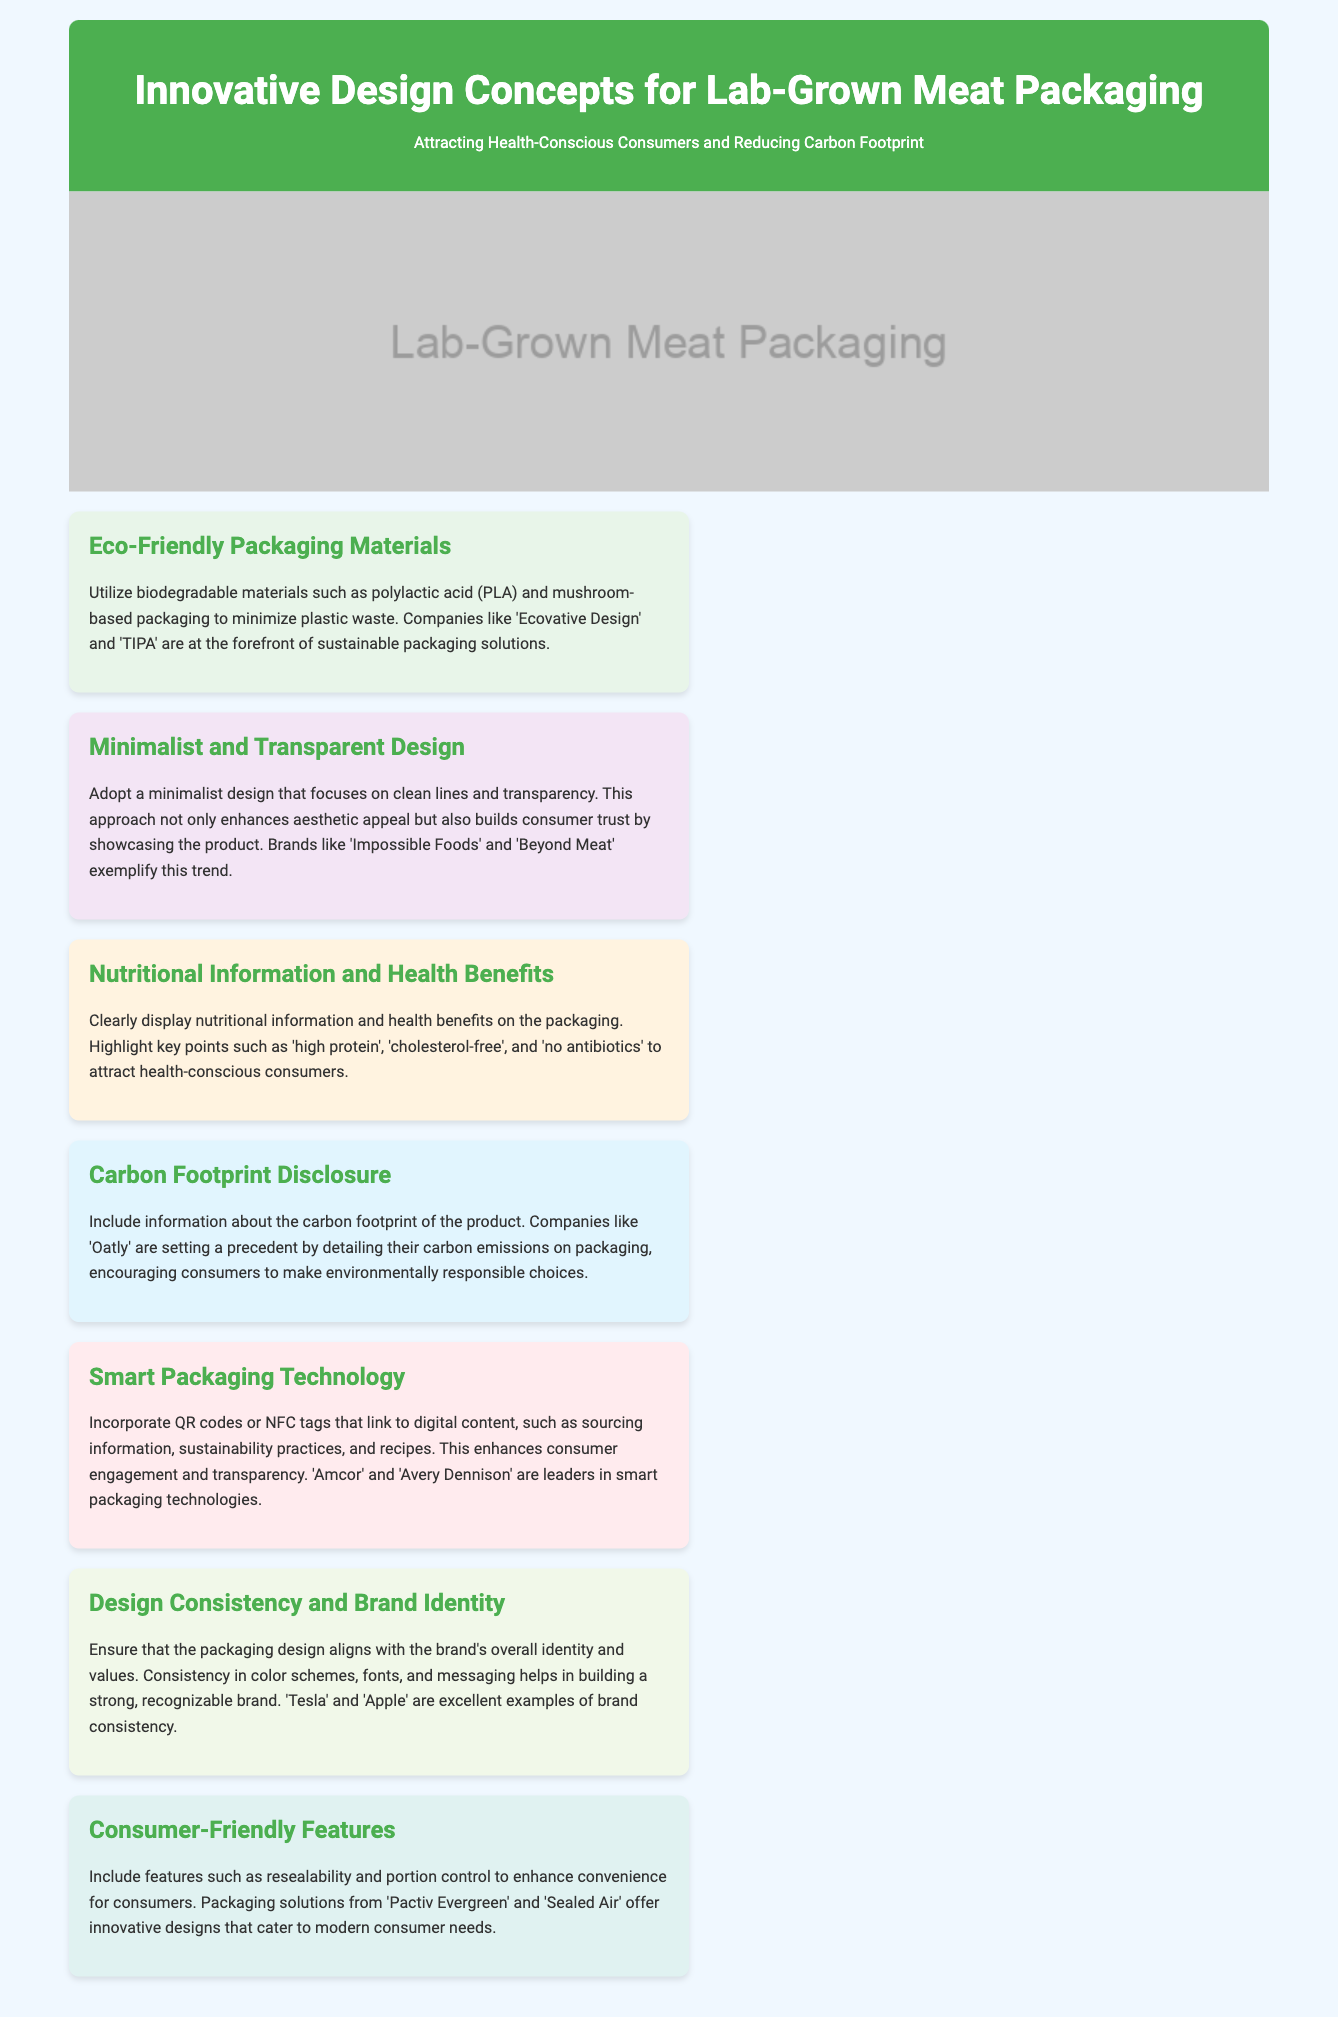What are the eco-friendly packaging materials mentioned? The document mentions biodegradable materials such as polylactic acid (PLA) and mushroom-based packaging as eco-friendly options.
Answer: PLA and mushroom-based packaging Which brands exemplify minimalist and transparent design? The brands 'Impossible Foods' and 'Beyond Meat' are cited as examples that adopt a minimalist design approach.
Answer: Impossible Foods and Beyond Meat What key nutritional points are highlighted on the packaging? The document states that packaging should highlight key points such as 'high protein', 'cholesterol-free', and 'no antibiotics' to attract health-conscious consumers.
Answer: High protein, cholesterol-free, no antibiotics What company sets a precedent by detailing carbon emissions on packaging? 'Oatly' is mentioned in the document as a company that provides information about its carbon footprint on the packaging.
Answer: Oatly What technology enhances consumer engagement according to the document? The document mentions the incorporation of QR codes or NFC tags linking to digital content to enhance consumer engagement.
Answer: QR codes or NFC tags What feature is included to enhance consumer convenience? Resealability and portion control are highlighted as features that enhance convenience for consumers.
Answer: Resealability and portion control Which companies are leaders in smart packaging technologies? 'Amcor' and 'Avery Dennison' are noted as leaders in the field of smart packaging technologies.
Answer: Amcor and Avery Dennison What should packaging design align with according to the document? The design should align with the brand's overall identity and values for consistency and recognition.
Answer: Brand's overall identity and values 